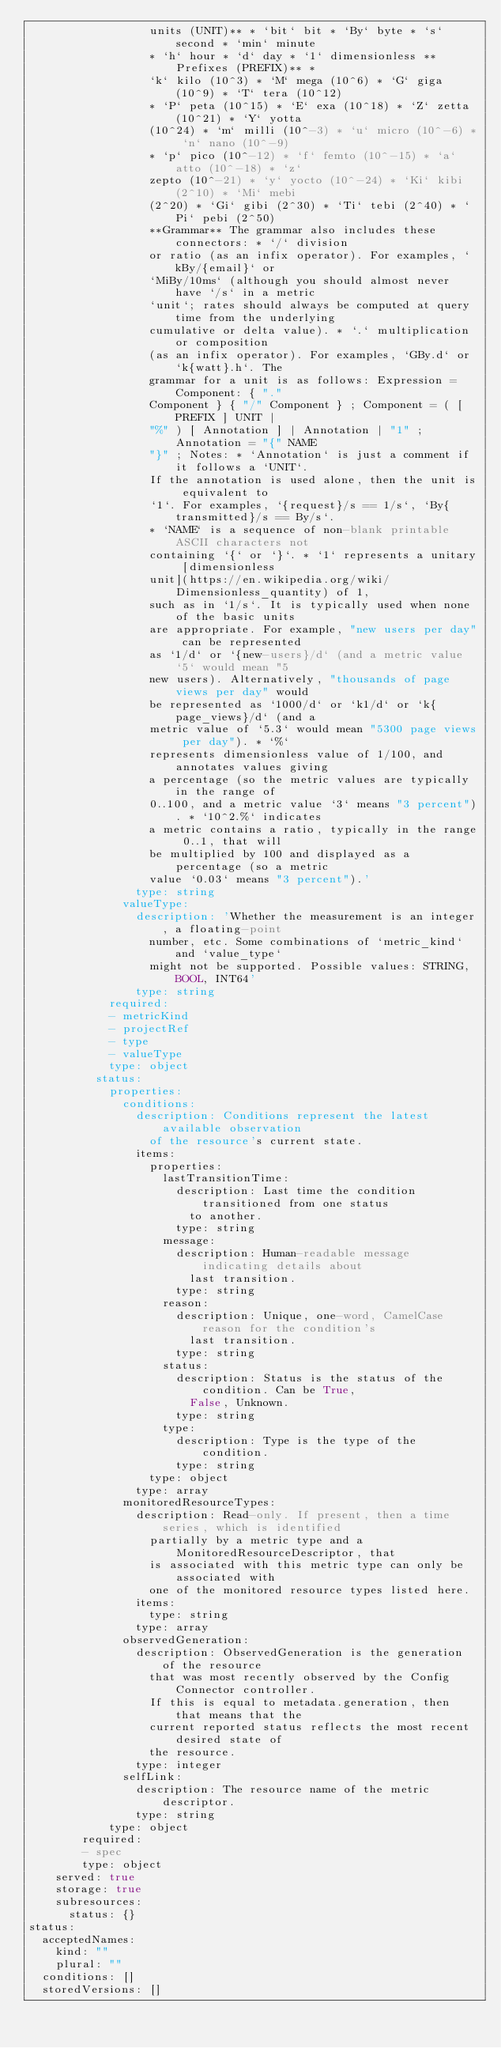Convert code to text. <code><loc_0><loc_0><loc_500><loc_500><_YAML_>                  units (UNIT)** * `bit` bit * `By` byte * `s` second * `min` minute
                  * `h` hour * `d` day * `1` dimensionless **Prefixes (PREFIX)** *
                  `k` kilo (10^3) * `M` mega (10^6) * `G` giga (10^9) * `T` tera (10^12)
                  * `P` peta (10^15) * `E` exa (10^18) * `Z` zetta (10^21) * `Y` yotta
                  (10^24) * `m` milli (10^-3) * `u` micro (10^-6) * `n` nano (10^-9)
                  * `p` pico (10^-12) * `f` femto (10^-15) * `a` atto (10^-18) * `z`
                  zepto (10^-21) * `y` yocto (10^-24) * `Ki` kibi (2^10) * `Mi` mebi
                  (2^20) * `Gi` gibi (2^30) * `Ti` tebi (2^40) * `Pi` pebi (2^50)
                  **Grammar** The grammar also includes these connectors: * `/` division
                  or ratio (as an infix operator). For examples, `kBy/{email}` or
                  `MiBy/10ms` (although you should almost never have `/s` in a metric
                  `unit`; rates should always be computed at query time from the underlying
                  cumulative or delta value). * `.` multiplication or composition
                  (as an infix operator). For examples, `GBy.d` or `k{watt}.h`. The
                  grammar for a unit is as follows: Expression = Component: { "."
                  Component } { "/" Component } ; Component = ( [ PREFIX ] UNIT |
                  "%" ) [ Annotation ] | Annotation | "1" ; Annotation = "{" NAME
                  "}" ; Notes: * `Annotation` is just a comment if it follows a `UNIT`.
                  If the annotation is used alone, then the unit is equivalent to
                  `1`. For examples, `{request}/s == 1/s`, `By{transmitted}/s == By/s`.
                  * `NAME` is a sequence of non-blank printable ASCII characters not
                  containing `{` or `}`. * `1` represents a unitary [dimensionless
                  unit](https://en.wikipedia.org/wiki/Dimensionless_quantity) of 1,
                  such as in `1/s`. It is typically used when none of the basic units
                  are appropriate. For example, "new users per day" can be represented
                  as `1/d` or `{new-users}/d` (and a metric value `5` would mean "5
                  new users). Alternatively, "thousands of page views per day" would
                  be represented as `1000/d` or `k1/d` or `k{page_views}/d` (and a
                  metric value of `5.3` would mean "5300 page views per day"). * `%`
                  represents dimensionless value of 1/100, and annotates values giving
                  a percentage (so the metric values are typically in the range of
                  0..100, and a metric value `3` means "3 percent"). * `10^2.%` indicates
                  a metric contains a ratio, typically in the range 0..1, that will
                  be multiplied by 100 and displayed as a percentage (so a metric
                  value `0.03` means "3 percent").'
                type: string
              valueType:
                description: 'Whether the measurement is an integer, a floating-point
                  number, etc. Some combinations of `metric_kind` and `value_type`
                  might not be supported. Possible values: STRING, BOOL, INT64'
                type: string
            required:
            - metricKind
            - projectRef
            - type
            - valueType
            type: object
          status:
            properties:
              conditions:
                description: Conditions represent the latest available observation
                  of the resource's current state.
                items:
                  properties:
                    lastTransitionTime:
                      description: Last time the condition transitioned from one status
                        to another.
                      type: string
                    message:
                      description: Human-readable message indicating details about
                        last transition.
                      type: string
                    reason:
                      description: Unique, one-word, CamelCase reason for the condition's
                        last transition.
                      type: string
                    status:
                      description: Status is the status of the condition. Can be True,
                        False, Unknown.
                      type: string
                    type:
                      description: Type is the type of the condition.
                      type: string
                  type: object
                type: array
              monitoredResourceTypes:
                description: Read-only. If present, then a time series, which is identified
                  partially by a metric type and a MonitoredResourceDescriptor, that
                  is associated with this metric type can only be associated with
                  one of the monitored resource types listed here.
                items:
                  type: string
                type: array
              observedGeneration:
                description: ObservedGeneration is the generation of the resource
                  that was most recently observed by the Config Connector controller.
                  If this is equal to metadata.generation, then that means that the
                  current reported status reflects the most recent desired state of
                  the resource.
                type: integer
              selfLink:
                description: The resource name of the metric descriptor.
                type: string
            type: object
        required:
        - spec
        type: object
    served: true
    storage: true
    subresources:
      status: {}
status:
  acceptedNames:
    kind: ""
    plural: ""
  conditions: []
  storedVersions: []
</code> 